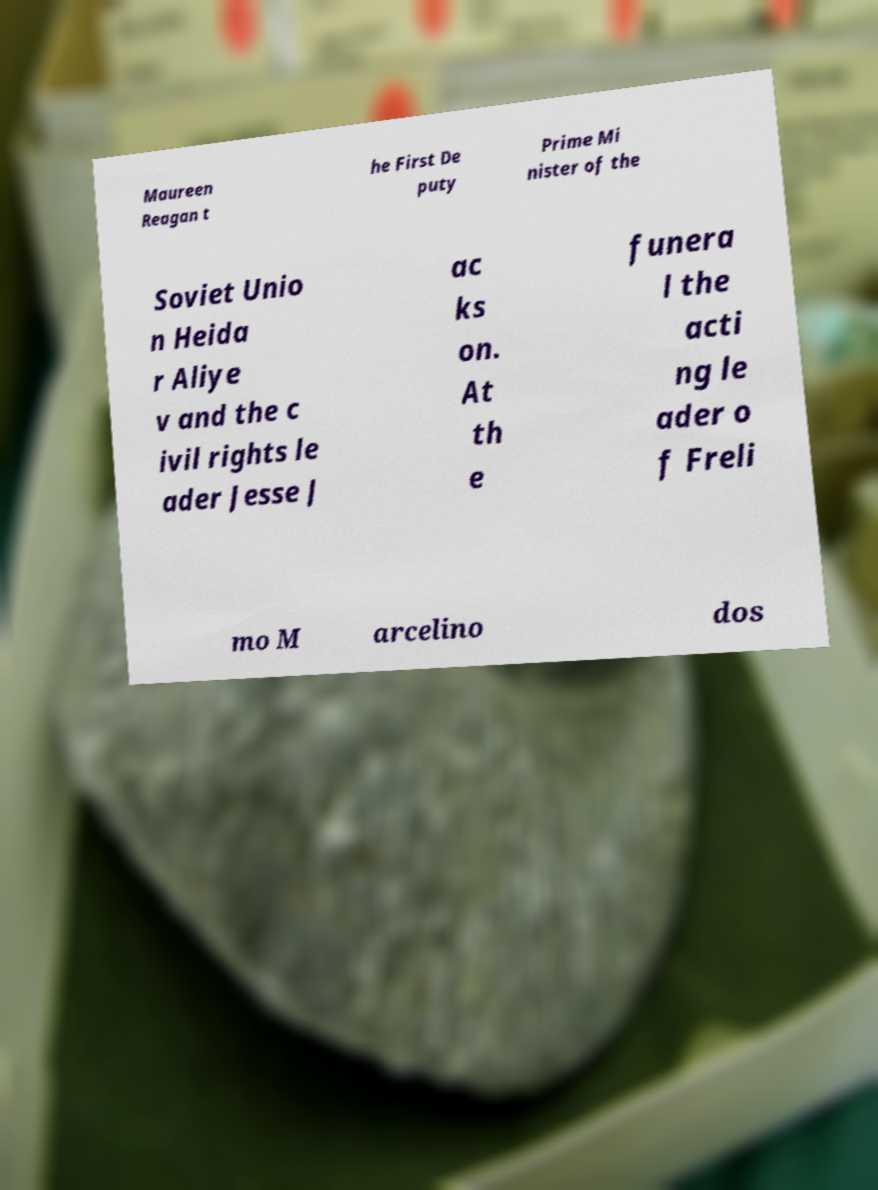For documentation purposes, I need the text within this image transcribed. Could you provide that? Maureen Reagan t he First De puty Prime Mi nister of the Soviet Unio n Heida r Aliye v and the c ivil rights le ader Jesse J ac ks on. At th e funera l the acti ng le ader o f Freli mo M arcelino dos 